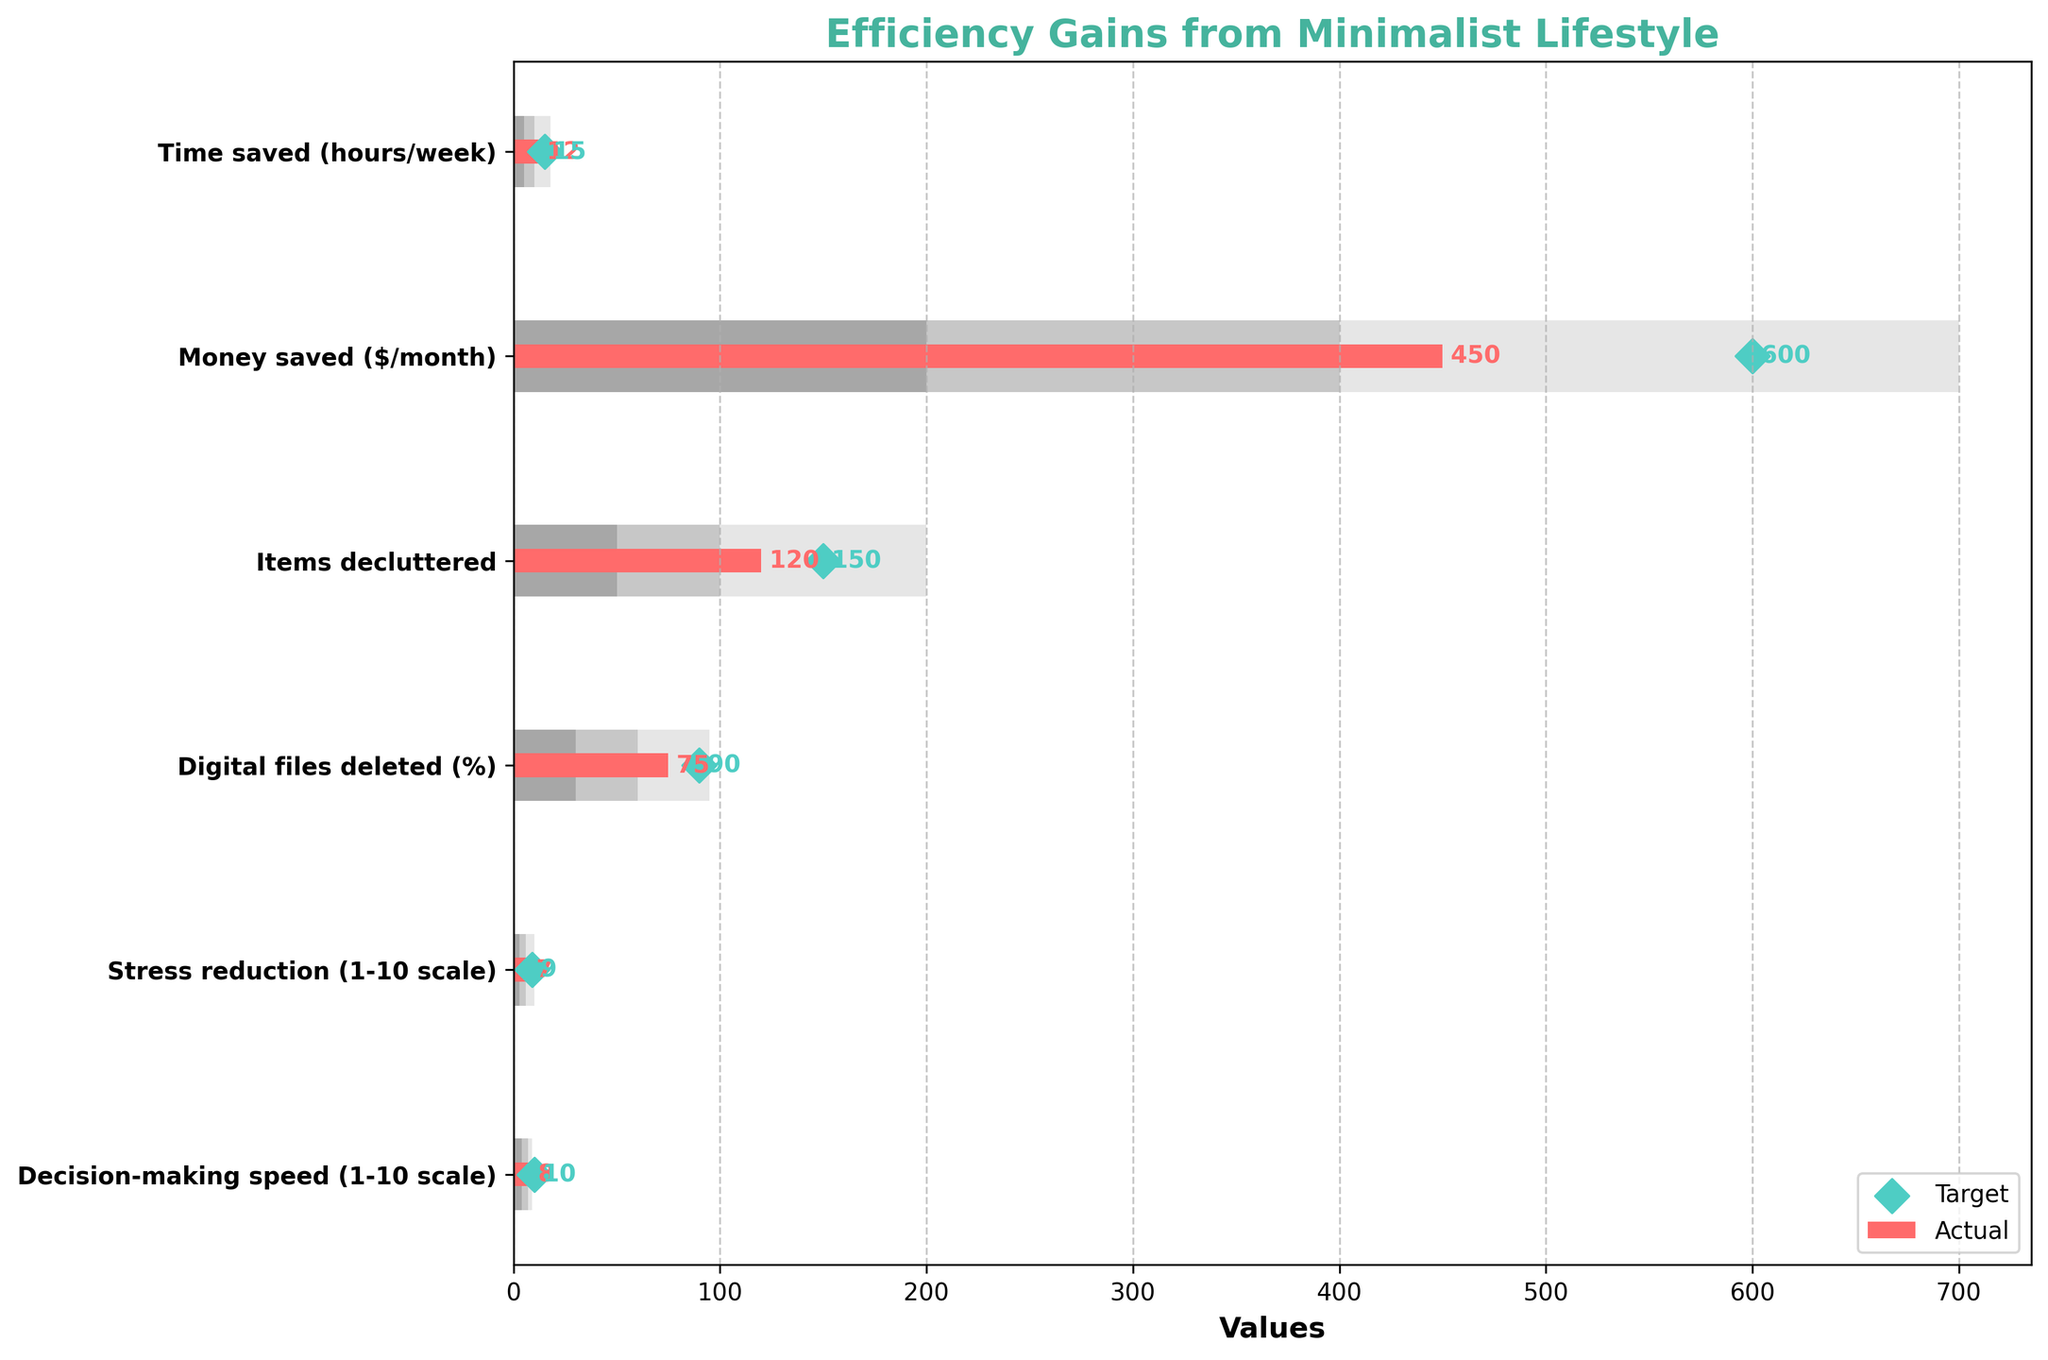What is the actual time saved per week by adopting minimalist lifestyle practices? The actual time saved is represented by the red bar on the horizontal axis for the "Time saved (hours/week)" category. The bar reaches up to 12.
Answer: 12 What is the target money saved per month? The target values are indicated by the green diamonds. For the "Money saved ($/month)" category, the green diamond is located at 600.
Answer: 600 Among the categories listed, which one has the highest actual value? To determine the highest actual value, compare the lengths of the red bars for each category. The highest actual value is for "Digital files deleted (%)", which is 75.
Answer: Digital files deleted (%) What is the difference between the target and actual values for decision-making speed? The target value for "Decision-making speed" is 10 and the actual value is 8. Subtract the actual value from the target value: 10 - 8 = 2.
Answer: 2 Which category exceeds the first range but does not reach the second range? The ranges are visualized using different shades of grey. "Time saved (hours/week)" with an actual value of 12 exceeds the first range (up to 5) but does not reach the second range (10-18).
Answer: Time saved (hours/week) Which category has almost achieved its target value with the least difference? Compare the actual values to their respective target values. "Decision-making speed" with an actual value of 8 and a target of 10 has the smallest difference of 2.
Answer: Decision-making speed How much more is the target value than the actual value for stress reduction? For "Stress reduction", the target value is 9 and the actual value is 7. The difference is 9 - 7 = 2.
Answer: 2 In which categories do the actual values fall within the second range? The second range is represented by the medium shade of grey. "Time saved (hours/week)" and "Money saved ($/month)" have actual values of 12 and 450, respectively, both within their second ranges.
Answer: Time saved (hours/week), Money saved ($/month) Compare the actual value of items decluttered with its target. Which one is greater? The actual value for "Items decluttered" is 120, while the target value is 150. The target value is greater.
Answer: Target What is the range of values in which the actual stress reduction falls? The actual stress reduction value is 7. This falls within the second range (6-10).
Answer: Second range 